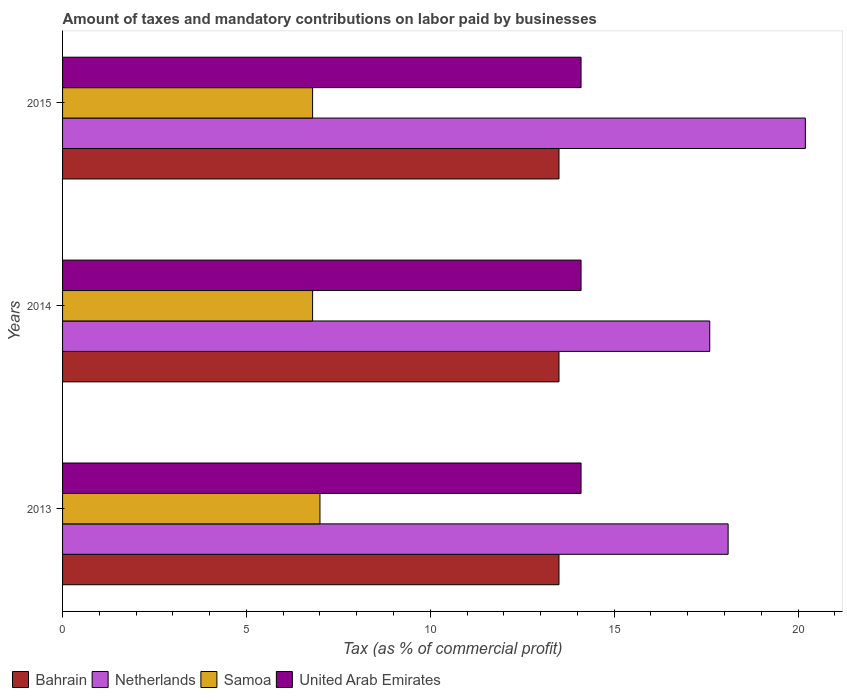How many different coloured bars are there?
Make the answer very short. 4. How many groups of bars are there?
Keep it short and to the point. 3. Are the number of bars per tick equal to the number of legend labels?
Provide a succinct answer. Yes. In how many cases, is the number of bars for a given year not equal to the number of legend labels?
Your answer should be compact. 0. What is the percentage of taxes paid by businesses in Samoa in 2015?
Offer a very short reply. 6.8. Across all years, what is the maximum percentage of taxes paid by businesses in Netherlands?
Provide a succinct answer. 20.2. What is the total percentage of taxes paid by businesses in United Arab Emirates in the graph?
Offer a terse response. 42.3. What is the difference between the percentage of taxes paid by businesses in Netherlands in 2014 and the percentage of taxes paid by businesses in Bahrain in 2015?
Offer a terse response. 4.1. In how many years, is the percentage of taxes paid by businesses in Samoa greater than 5 %?
Give a very brief answer. 3. Is the percentage of taxes paid by businesses in Netherlands in 2013 less than that in 2015?
Make the answer very short. Yes. Is the difference between the percentage of taxes paid by businesses in Samoa in 2013 and 2014 greater than the difference between the percentage of taxes paid by businesses in Bahrain in 2013 and 2014?
Keep it short and to the point. Yes. What is the difference between the highest and the second highest percentage of taxes paid by businesses in Netherlands?
Your response must be concise. 2.1. What is the difference between the highest and the lowest percentage of taxes paid by businesses in Netherlands?
Offer a very short reply. 2.6. In how many years, is the percentage of taxes paid by businesses in Bahrain greater than the average percentage of taxes paid by businesses in Bahrain taken over all years?
Your answer should be very brief. 0. What does the 2nd bar from the top in 2013 represents?
Offer a terse response. Samoa. What does the 4th bar from the bottom in 2013 represents?
Keep it short and to the point. United Arab Emirates. How many bars are there?
Provide a succinct answer. 12. How many years are there in the graph?
Your answer should be compact. 3. Does the graph contain any zero values?
Give a very brief answer. No. Does the graph contain grids?
Make the answer very short. No. How many legend labels are there?
Offer a very short reply. 4. What is the title of the graph?
Offer a very short reply. Amount of taxes and mandatory contributions on labor paid by businesses. Does "Latvia" appear as one of the legend labels in the graph?
Offer a very short reply. No. What is the label or title of the X-axis?
Ensure brevity in your answer.  Tax (as % of commercial profit). What is the label or title of the Y-axis?
Give a very brief answer. Years. What is the Tax (as % of commercial profit) of Netherlands in 2013?
Keep it short and to the point. 18.1. What is the Tax (as % of commercial profit) of Samoa in 2013?
Provide a succinct answer. 7. What is the Tax (as % of commercial profit) in Bahrain in 2014?
Ensure brevity in your answer.  13.5. What is the Tax (as % of commercial profit) of Samoa in 2014?
Provide a succinct answer. 6.8. What is the Tax (as % of commercial profit) of Netherlands in 2015?
Provide a short and direct response. 20.2. What is the Tax (as % of commercial profit) in United Arab Emirates in 2015?
Ensure brevity in your answer.  14.1. Across all years, what is the maximum Tax (as % of commercial profit) of Bahrain?
Make the answer very short. 13.5. Across all years, what is the maximum Tax (as % of commercial profit) of Netherlands?
Ensure brevity in your answer.  20.2. Across all years, what is the maximum Tax (as % of commercial profit) in Samoa?
Provide a short and direct response. 7. Across all years, what is the minimum Tax (as % of commercial profit) in United Arab Emirates?
Your answer should be compact. 14.1. What is the total Tax (as % of commercial profit) of Bahrain in the graph?
Make the answer very short. 40.5. What is the total Tax (as % of commercial profit) in Netherlands in the graph?
Offer a very short reply. 55.9. What is the total Tax (as % of commercial profit) in Samoa in the graph?
Your answer should be very brief. 20.6. What is the total Tax (as % of commercial profit) in United Arab Emirates in the graph?
Give a very brief answer. 42.3. What is the difference between the Tax (as % of commercial profit) of Bahrain in 2013 and that in 2014?
Keep it short and to the point. 0. What is the difference between the Tax (as % of commercial profit) in Netherlands in 2013 and that in 2014?
Keep it short and to the point. 0.5. What is the difference between the Tax (as % of commercial profit) of Bahrain in 2013 and that in 2015?
Your response must be concise. 0. What is the difference between the Tax (as % of commercial profit) in Samoa in 2013 and that in 2015?
Your answer should be very brief. 0.2. What is the difference between the Tax (as % of commercial profit) in United Arab Emirates in 2013 and that in 2015?
Offer a terse response. 0. What is the difference between the Tax (as % of commercial profit) of Netherlands in 2014 and that in 2015?
Your response must be concise. -2.6. What is the difference between the Tax (as % of commercial profit) of Samoa in 2014 and that in 2015?
Offer a very short reply. 0. What is the difference between the Tax (as % of commercial profit) in Bahrain in 2013 and the Tax (as % of commercial profit) in Netherlands in 2014?
Provide a succinct answer. -4.1. What is the difference between the Tax (as % of commercial profit) in Bahrain in 2013 and the Tax (as % of commercial profit) in Samoa in 2014?
Offer a very short reply. 6.7. What is the difference between the Tax (as % of commercial profit) in Bahrain in 2013 and the Tax (as % of commercial profit) in United Arab Emirates in 2014?
Give a very brief answer. -0.6. What is the difference between the Tax (as % of commercial profit) in Netherlands in 2013 and the Tax (as % of commercial profit) in Samoa in 2014?
Your answer should be compact. 11.3. What is the difference between the Tax (as % of commercial profit) in Netherlands in 2013 and the Tax (as % of commercial profit) in United Arab Emirates in 2014?
Offer a terse response. 4. What is the difference between the Tax (as % of commercial profit) in Samoa in 2013 and the Tax (as % of commercial profit) in United Arab Emirates in 2014?
Your response must be concise. -7.1. What is the difference between the Tax (as % of commercial profit) of Bahrain in 2013 and the Tax (as % of commercial profit) of Samoa in 2015?
Give a very brief answer. 6.7. What is the difference between the Tax (as % of commercial profit) of Netherlands in 2013 and the Tax (as % of commercial profit) of United Arab Emirates in 2015?
Give a very brief answer. 4. What is the difference between the Tax (as % of commercial profit) of Bahrain in 2014 and the Tax (as % of commercial profit) of Netherlands in 2015?
Provide a short and direct response. -6.7. What is the difference between the Tax (as % of commercial profit) of Bahrain in 2014 and the Tax (as % of commercial profit) of Samoa in 2015?
Offer a terse response. 6.7. What is the difference between the Tax (as % of commercial profit) in Netherlands in 2014 and the Tax (as % of commercial profit) in United Arab Emirates in 2015?
Offer a terse response. 3.5. What is the average Tax (as % of commercial profit) in Bahrain per year?
Ensure brevity in your answer.  13.5. What is the average Tax (as % of commercial profit) in Netherlands per year?
Your response must be concise. 18.63. What is the average Tax (as % of commercial profit) of Samoa per year?
Make the answer very short. 6.87. In the year 2013, what is the difference between the Tax (as % of commercial profit) in Bahrain and Tax (as % of commercial profit) in Samoa?
Ensure brevity in your answer.  6.5. In the year 2013, what is the difference between the Tax (as % of commercial profit) of Netherlands and Tax (as % of commercial profit) of United Arab Emirates?
Make the answer very short. 4. In the year 2014, what is the difference between the Tax (as % of commercial profit) of Bahrain and Tax (as % of commercial profit) of Netherlands?
Your response must be concise. -4.1. In the year 2014, what is the difference between the Tax (as % of commercial profit) in Bahrain and Tax (as % of commercial profit) in Samoa?
Provide a succinct answer. 6.7. In the year 2014, what is the difference between the Tax (as % of commercial profit) in Bahrain and Tax (as % of commercial profit) in United Arab Emirates?
Provide a short and direct response. -0.6. In the year 2015, what is the difference between the Tax (as % of commercial profit) of Bahrain and Tax (as % of commercial profit) of Netherlands?
Provide a succinct answer. -6.7. In the year 2015, what is the difference between the Tax (as % of commercial profit) of Bahrain and Tax (as % of commercial profit) of Samoa?
Provide a short and direct response. 6.7. In the year 2015, what is the difference between the Tax (as % of commercial profit) in Bahrain and Tax (as % of commercial profit) in United Arab Emirates?
Give a very brief answer. -0.6. In the year 2015, what is the difference between the Tax (as % of commercial profit) of Netherlands and Tax (as % of commercial profit) of United Arab Emirates?
Provide a succinct answer. 6.1. What is the ratio of the Tax (as % of commercial profit) of Bahrain in 2013 to that in 2014?
Offer a terse response. 1. What is the ratio of the Tax (as % of commercial profit) in Netherlands in 2013 to that in 2014?
Make the answer very short. 1.03. What is the ratio of the Tax (as % of commercial profit) of Samoa in 2013 to that in 2014?
Your answer should be compact. 1.03. What is the ratio of the Tax (as % of commercial profit) in United Arab Emirates in 2013 to that in 2014?
Make the answer very short. 1. What is the ratio of the Tax (as % of commercial profit) in Bahrain in 2013 to that in 2015?
Make the answer very short. 1. What is the ratio of the Tax (as % of commercial profit) of Netherlands in 2013 to that in 2015?
Make the answer very short. 0.9. What is the ratio of the Tax (as % of commercial profit) of Samoa in 2013 to that in 2015?
Provide a succinct answer. 1.03. What is the ratio of the Tax (as % of commercial profit) of United Arab Emirates in 2013 to that in 2015?
Keep it short and to the point. 1. What is the ratio of the Tax (as % of commercial profit) in Bahrain in 2014 to that in 2015?
Give a very brief answer. 1. What is the ratio of the Tax (as % of commercial profit) of Netherlands in 2014 to that in 2015?
Provide a succinct answer. 0.87. What is the difference between the highest and the second highest Tax (as % of commercial profit) of Bahrain?
Ensure brevity in your answer.  0. What is the difference between the highest and the second highest Tax (as % of commercial profit) of Netherlands?
Your response must be concise. 2.1. What is the difference between the highest and the lowest Tax (as % of commercial profit) in Netherlands?
Make the answer very short. 2.6. 